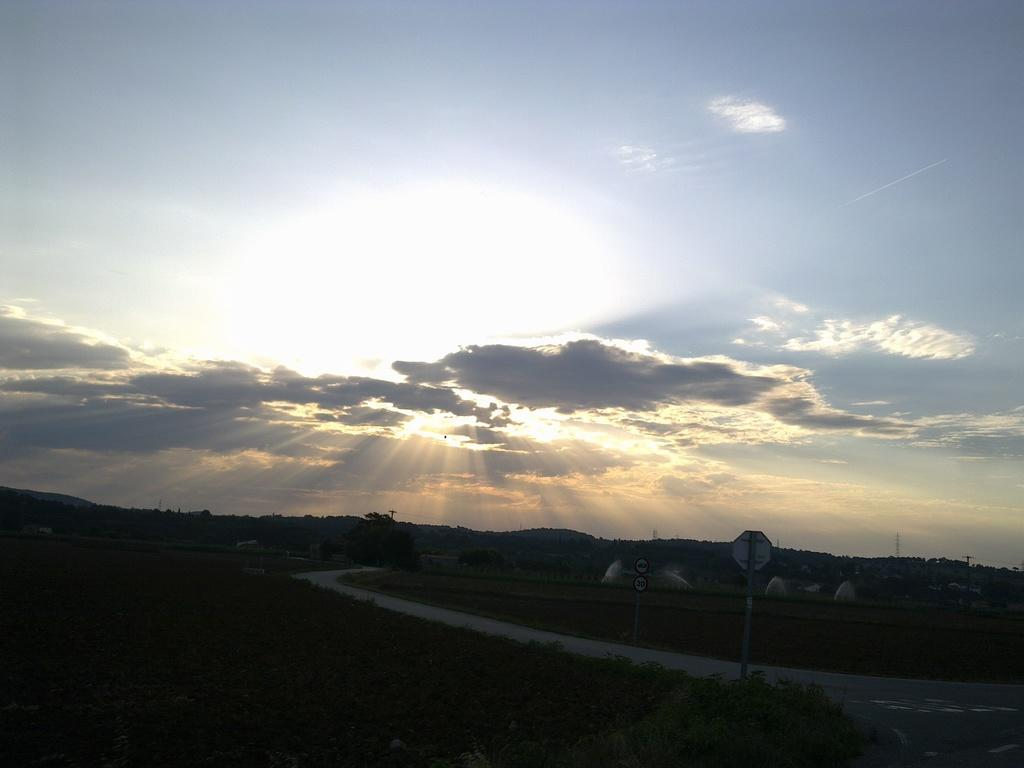What is the main feature of the image? There is a road in the image. What can be seen on the left side of the image? There are trees on the left side of the image. What can be seen on the right side of the image? There are trees on the right side of the image. What type of vegetation is present in the image? There are plants in the image. What is visible in the sky at the top of the image? There are clouds in the sky at the top of the image. What type of zipper can be seen on the creature in the image? There is no creature or zipper present in the image. What behavior is exhibited by the plants in the image? The plants in the image are stationary and do not exhibit any behavior. 